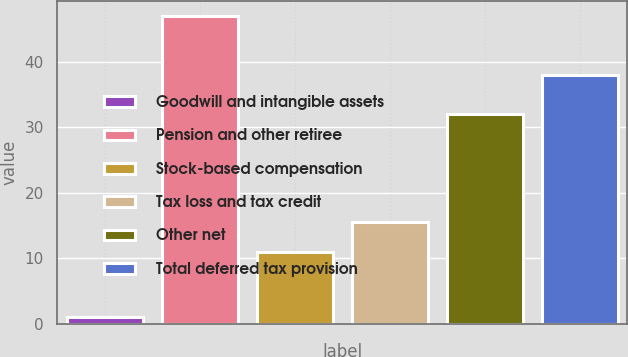Convert chart to OTSL. <chart><loc_0><loc_0><loc_500><loc_500><bar_chart><fcel>Goodwill and intangible assets<fcel>Pension and other retiree<fcel>Stock-based compensation<fcel>Tax loss and tax credit<fcel>Other net<fcel>Total deferred tax provision<nl><fcel>1<fcel>47<fcel>11<fcel>15.6<fcel>32<fcel>38<nl></chart> 